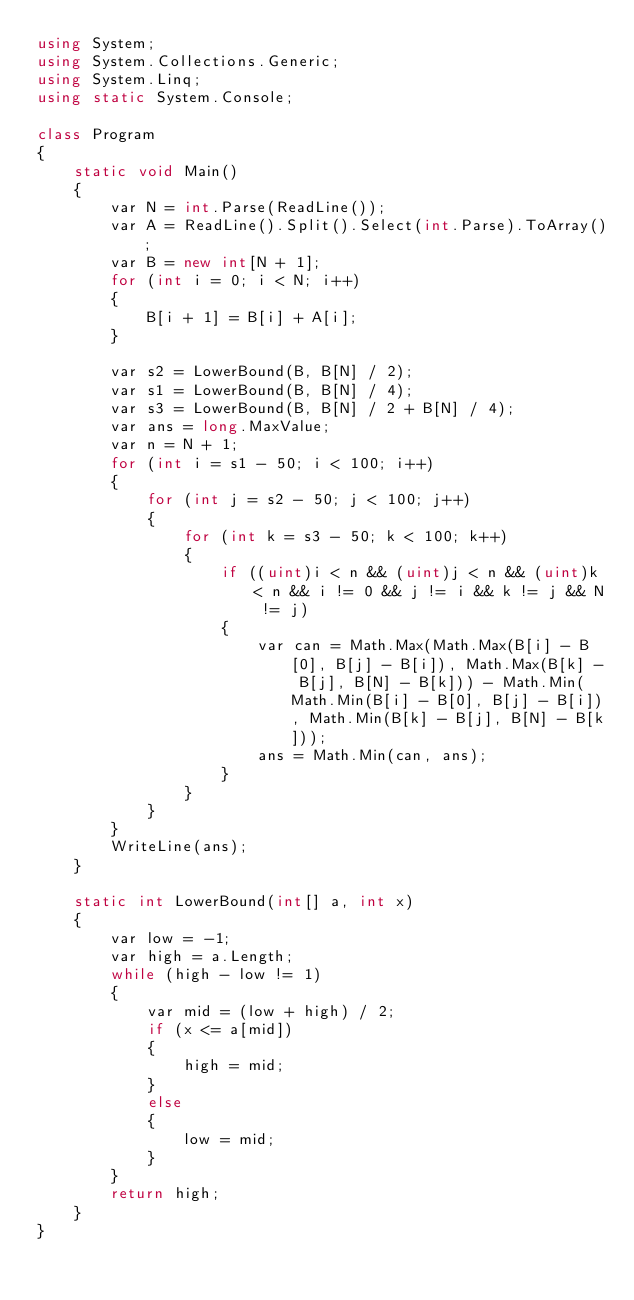<code> <loc_0><loc_0><loc_500><loc_500><_C#_>using System;
using System.Collections.Generic;
using System.Linq;
using static System.Console;

class Program
{
    static void Main()
    {
        var N = int.Parse(ReadLine());
        var A = ReadLine().Split().Select(int.Parse).ToArray();
        var B = new int[N + 1];
        for (int i = 0; i < N; i++)
        {
            B[i + 1] = B[i] + A[i];
        }

        var s2 = LowerBound(B, B[N] / 2);
        var s1 = LowerBound(B, B[N] / 4);
        var s3 = LowerBound(B, B[N] / 2 + B[N] / 4);
        var ans = long.MaxValue;
        var n = N + 1;
        for (int i = s1 - 50; i < 100; i++)
        {
            for (int j = s2 - 50; j < 100; j++)
            {
                for (int k = s3 - 50; k < 100; k++)
                {
                    if ((uint)i < n && (uint)j < n && (uint)k < n && i != 0 && j != i && k != j && N != j)
                    {
                        var can = Math.Max(Math.Max(B[i] - B[0], B[j] - B[i]), Math.Max(B[k] - B[j], B[N] - B[k])) - Math.Min(Math.Min(B[i] - B[0], B[j] - B[i]), Math.Min(B[k] - B[j], B[N] - B[k]));
                        ans = Math.Min(can, ans);
                    }
                }
            }
        }
        WriteLine(ans);
    }

    static int LowerBound(int[] a, int x)
    {
        var low = -1;
        var high = a.Length;
        while (high - low != 1)
        {
            var mid = (low + high) / 2;
            if (x <= a[mid])
            {
                high = mid;
            }
            else
            {
                low = mid;
            }
        }
        return high;
    }
}</code> 